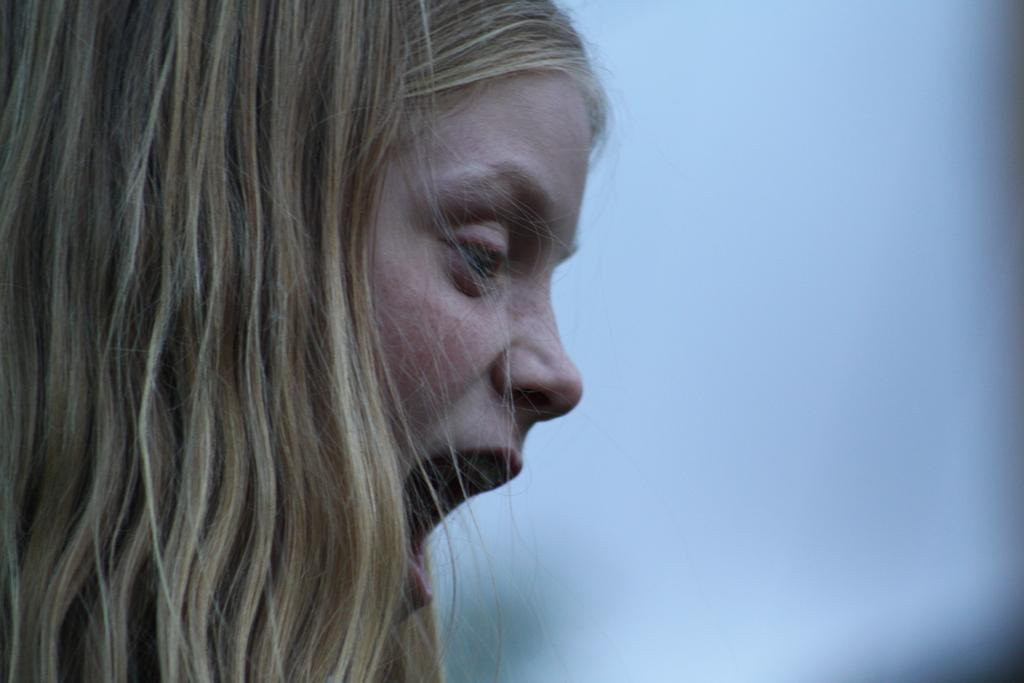What is the main subject in the foreground of the image? There is a woman in the foreground of the image. What is the woman doing in the image? The woman has her mouth opened. What type of instrument is the woman playing in the image? There is no instrument present in the image; the woman has her mouth opened, but there is no indication of her playing an instrument. What type of berry can be seen in the woman's hand in the image? There is no berry present in the image; the woman has her mouth opened, but there is no berry visible. 